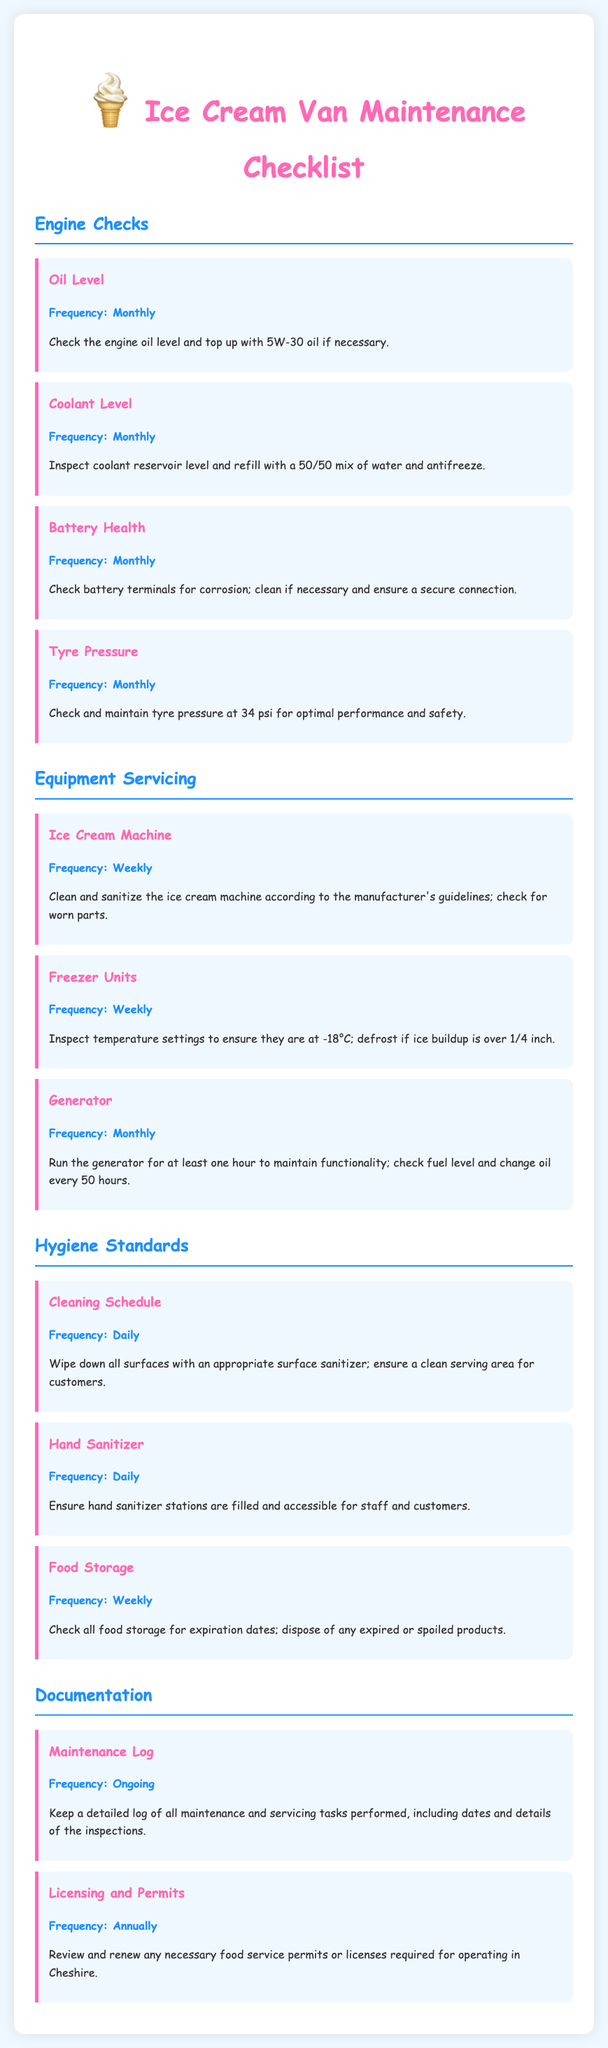What is the frequency for checking the oil level? The frequency for checking the oil level is mentioned under the "Engine Checks" section.
Answer: Monthly What temperature should freezer units be set to? The ideal temperature setting for freezer units is specified in the "Equipment Servicing" section.
Answer: -18°C How often should hand sanitizer stations be filled? The frequency for filling hand sanitizer stations is noted under the "Hygiene Standards" section.
Answer: Daily What task should be completed every week for the ice cream machine? Weekly tasks for the ice cream machine are described in the "Equipment Servicing" section.
Answer: Clean and sanitize Which document item needs to be reviewed annually? The annual review is detailed under the "Documentation" section.
Answer: Licensing and Permits What should be done with expired food storage items? The required action is provided in the "Hygiene Standards" section.
Answer: Dispose How often should the generator be checked? The maintenance frequency for the generator is stated in the "Equipment Servicing" section.
Answer: Monthly What is required for the maintenance log? The requirements for the maintenance log are outlined in the "Documentation" section.
Answer: Detailed log 